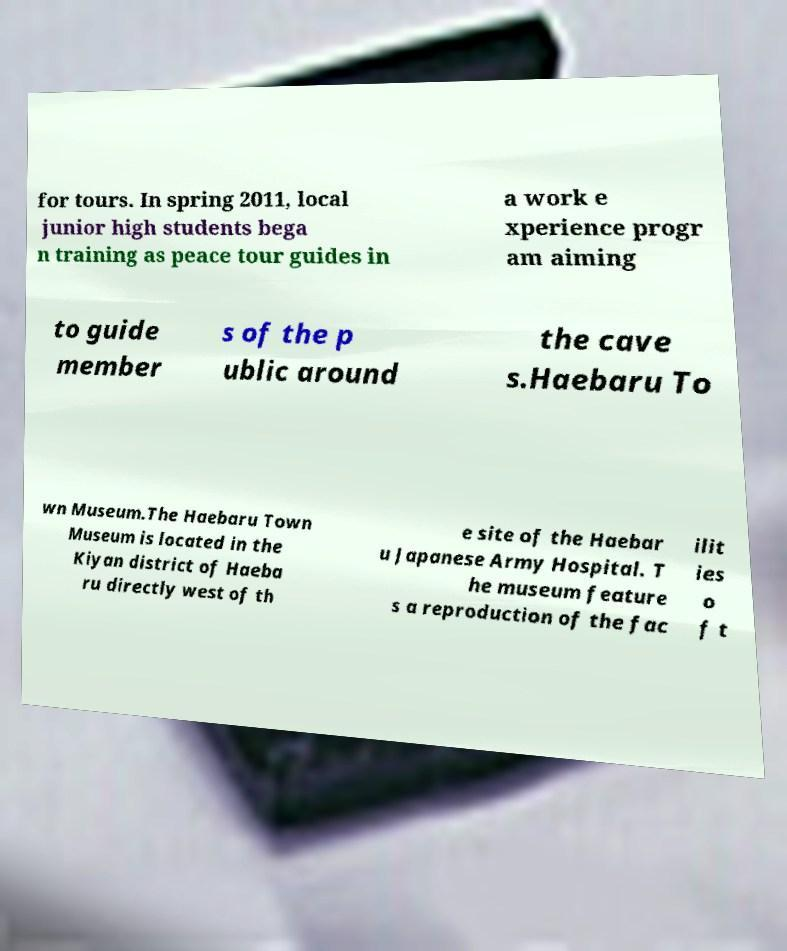Please identify and transcribe the text found in this image. for tours. In spring 2011, local junior high students bega n training as peace tour guides in a work e xperience progr am aiming to guide member s of the p ublic around the cave s.Haebaru To wn Museum.The Haebaru Town Museum is located in the Kiyan district of Haeba ru directly west of th e site of the Haebar u Japanese Army Hospital. T he museum feature s a reproduction of the fac ilit ies o f t 